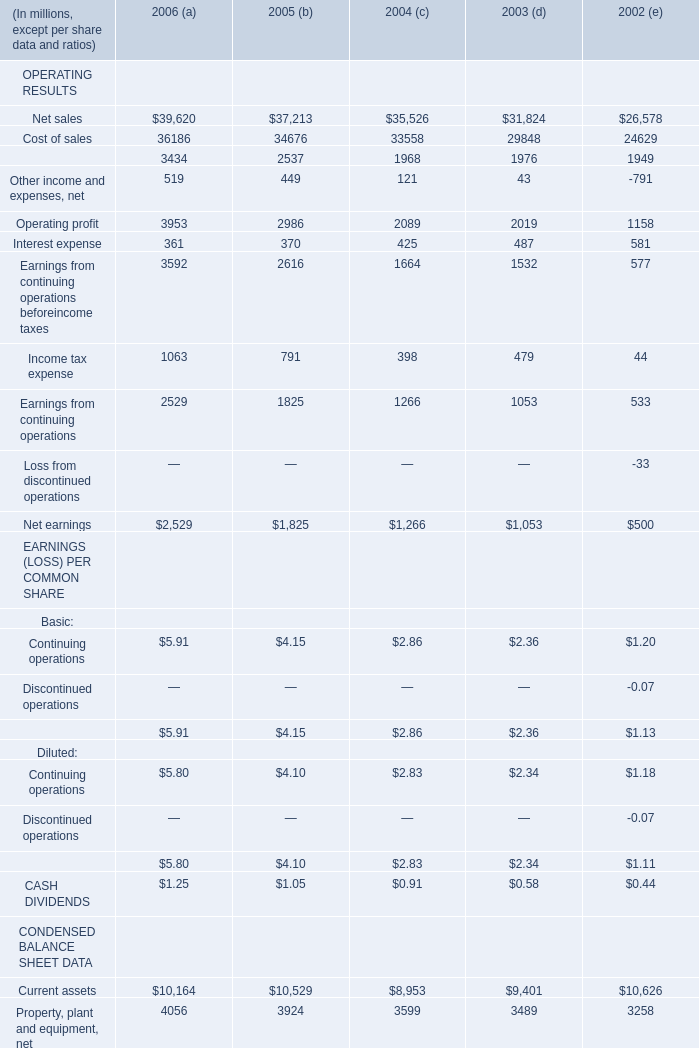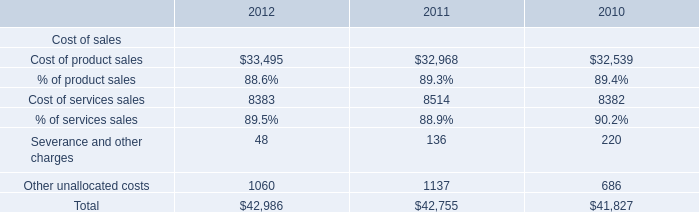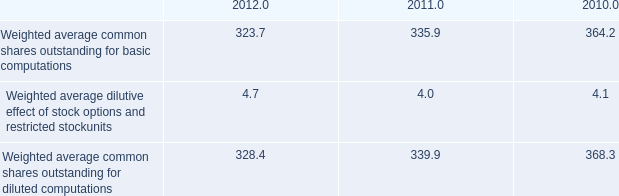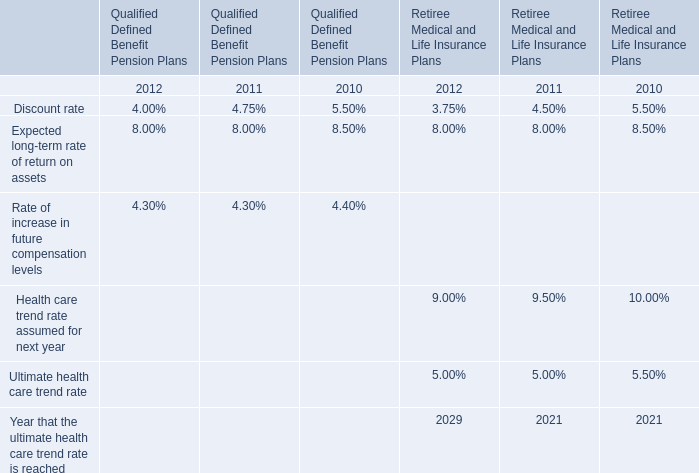what was the percent of the change in weighted average common shares outstanding for diluted computations from 2011 to 2012 
Computations: ((328.4 - 339.9) / 339.9)
Answer: -0.03383. 